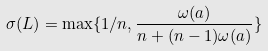Convert formula to latex. <formula><loc_0><loc_0><loc_500><loc_500>\sigma ( L ) = \max \{ 1 / n , \frac { \omega ( a ) } { n + ( n - 1 ) \omega ( a ) } \}</formula> 